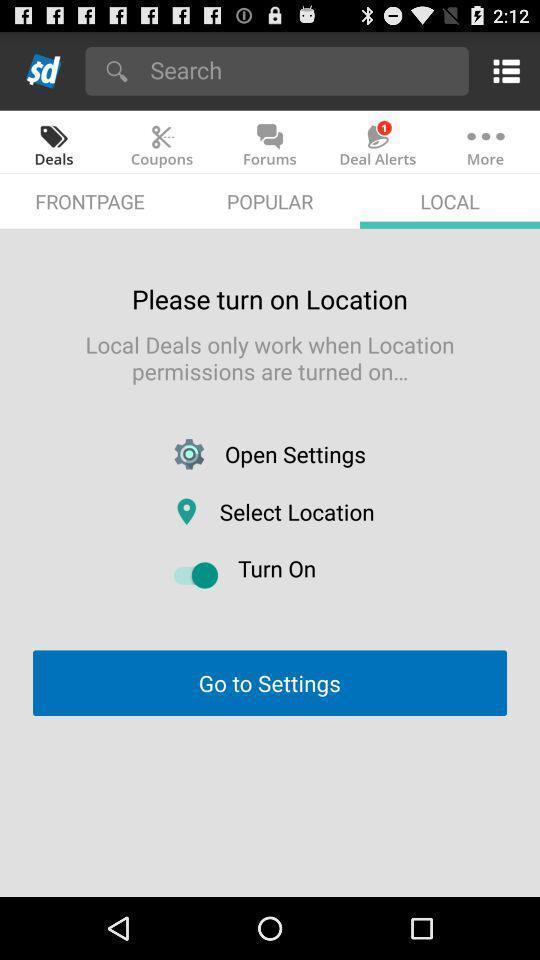Please provide a description for this image. Settings page showing various options with search bar. 